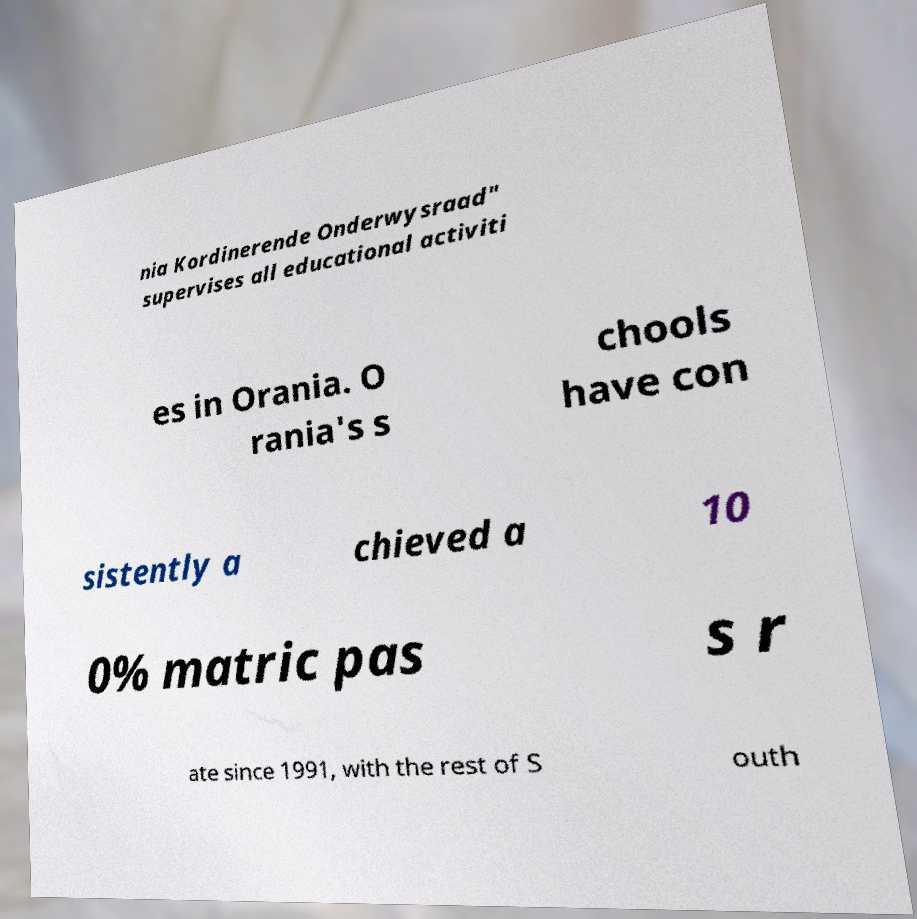I need the written content from this picture converted into text. Can you do that? nia Kordinerende Onderwysraad" supervises all educational activiti es in Orania. O rania's s chools have con sistently a chieved a 10 0% matric pas s r ate since 1991, with the rest of S outh 